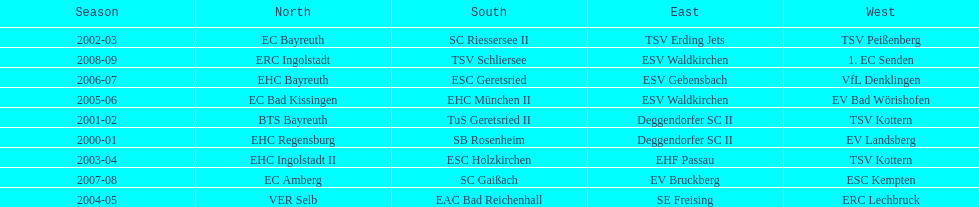Give me the full table as a dictionary. {'header': ['Season', 'North', 'South', 'East', 'West'], 'rows': [['2002-03', 'EC Bayreuth', 'SC Riessersee II', 'TSV Erding Jets', 'TSV Peißenberg'], ['2008-09', 'ERC Ingolstadt', 'TSV Schliersee', 'ESV Waldkirchen', '1. EC Senden'], ['2006-07', 'EHC Bayreuth', 'ESC Geretsried', 'ESV Gebensbach', 'VfL Denklingen'], ['2005-06', 'EC Bad Kissingen', 'EHC München II', 'ESV Waldkirchen', 'EV Bad Wörishofen'], ['2001-02', 'BTS Bayreuth', 'TuS Geretsried II', 'Deggendorfer SC II', 'TSV Kottern'], ['2000-01', 'EHC Regensburg', 'SB Rosenheim', 'Deggendorfer SC II', 'EV Landsberg'], ['2003-04', 'EHC Ingolstadt II', 'ESC Holzkirchen', 'EHF Passau', 'TSV Kottern'], ['2007-08', 'EC Amberg', 'SC Gaißach', 'EV Bruckberg', 'ESC Kempten'], ['2004-05', 'VER Selb', 'EAC Bad Reichenhall', 'SE Freising', 'ERC Lechbruck']]} What is the number of seasons covered in the table? 9. 